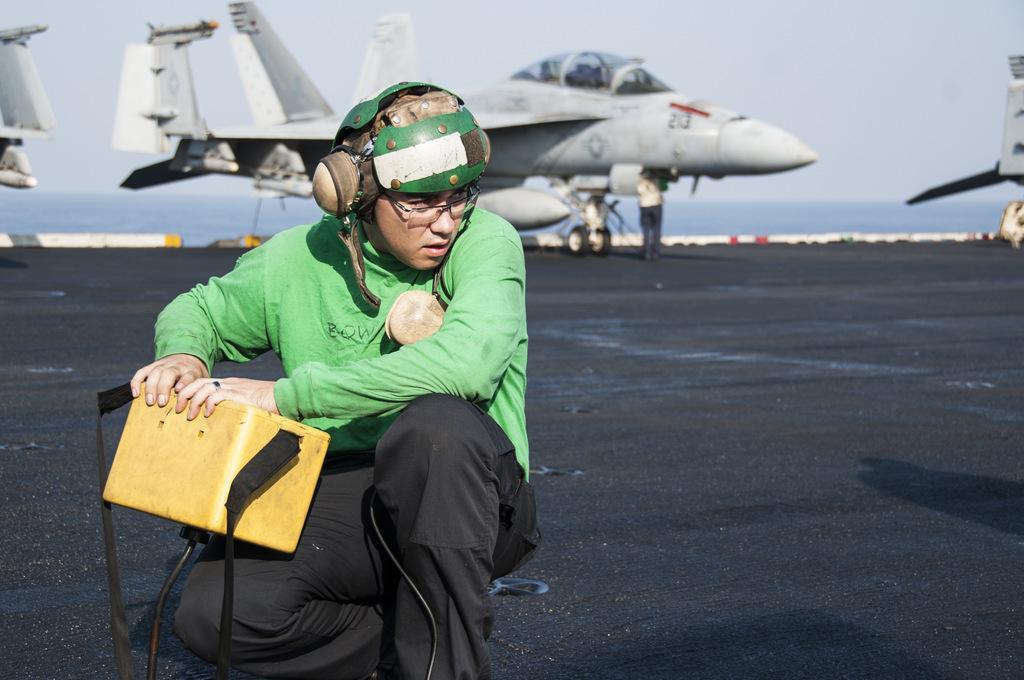Describe this image in one or two sentences. In this picture we can see a person is holding a box in the front, in the background we can see jet planes and water, there is the sky at the top of the picture. 